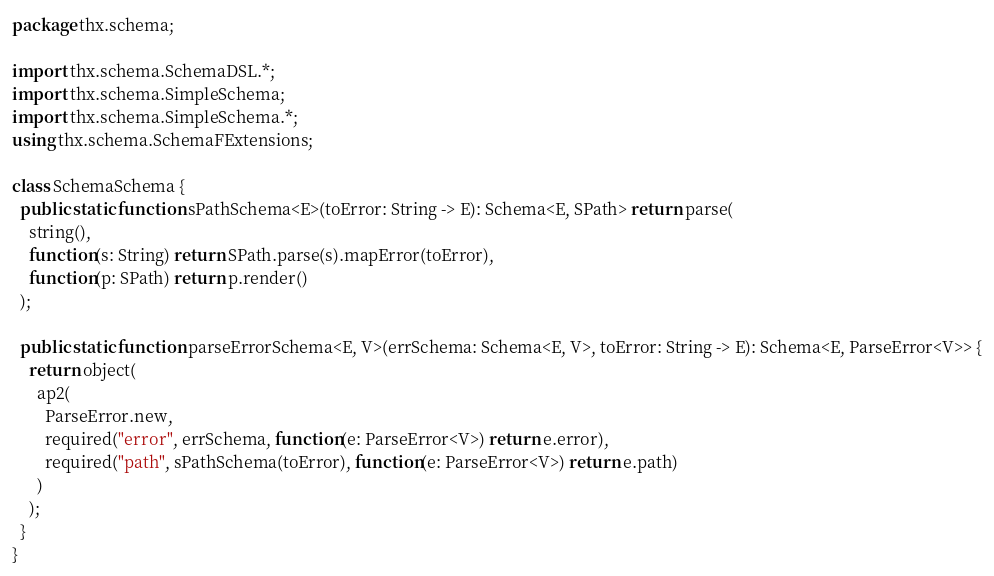<code> <loc_0><loc_0><loc_500><loc_500><_Haxe_>package thx.schema;

import thx.schema.SchemaDSL.*;
import thx.schema.SimpleSchema;
import thx.schema.SimpleSchema.*;
using thx.schema.SchemaFExtensions;

class SchemaSchema {
  public static function sPathSchema<E>(toError: String -> E): Schema<E, SPath> return parse(
    string(), 
    function(s: String) return SPath.parse(s).mapError(toError), 
    function(p: SPath) return p.render()
  );

  public static function parseErrorSchema<E, V>(errSchema: Schema<E, V>, toError: String -> E): Schema<E, ParseError<V>> {
    return object(
      ap2(
        ParseError.new,
        required("error", errSchema, function(e: ParseError<V>) return e.error),
        required("path", sPathSchema(toError), function(e: ParseError<V>) return e.path)
      )
    );
  }
}
</code> 